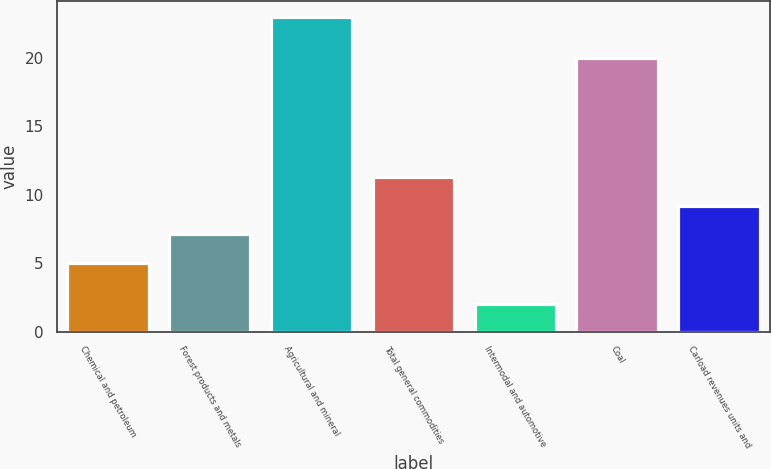Convert chart. <chart><loc_0><loc_0><loc_500><loc_500><bar_chart><fcel>Chemical and petroleum<fcel>Forest products and metals<fcel>Agricultural and mineral<fcel>Total general commodities<fcel>Intermodal and automotive<fcel>Coal<fcel>Carload revenues units and<nl><fcel>5<fcel>7.1<fcel>23<fcel>11.3<fcel>2<fcel>20<fcel>9.2<nl></chart> 